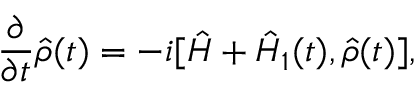<formula> <loc_0><loc_0><loc_500><loc_500>\frac { \partial } { \partial t } \hat { \rho } ( t ) = - i [ \hat { H } + \hat { H } _ { 1 } ( t ) , \hat { \rho } ( t ) ] ,</formula> 